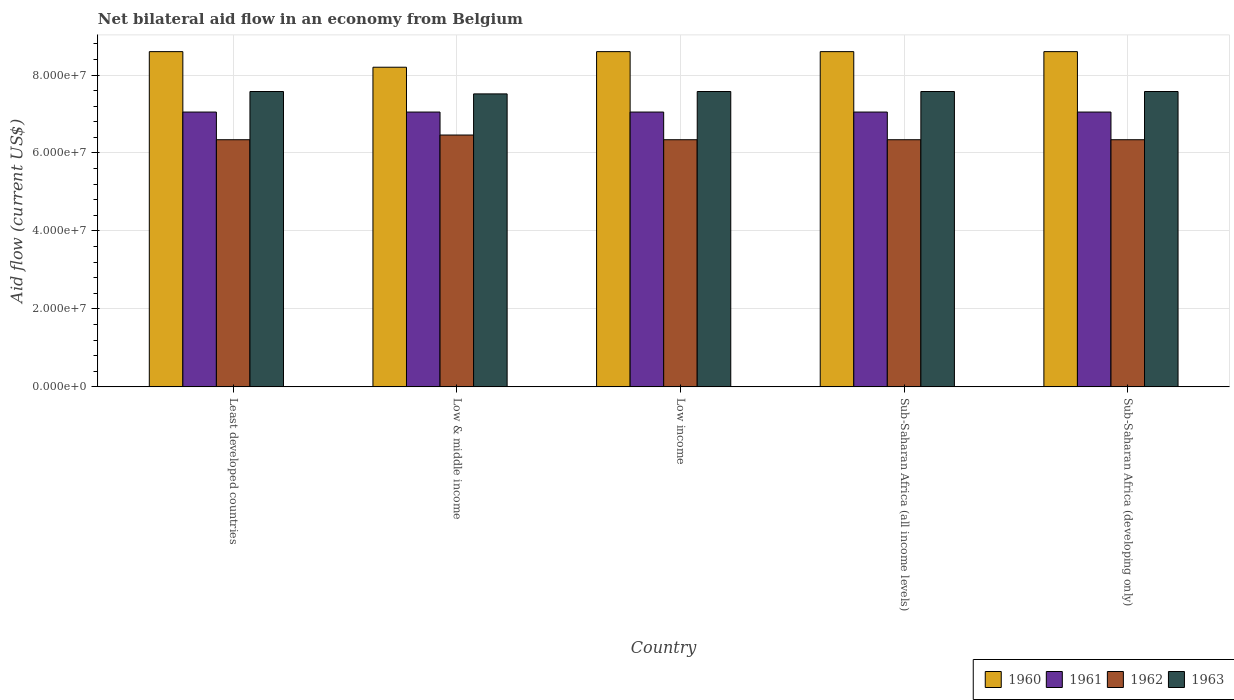How many groups of bars are there?
Offer a very short reply. 5. How many bars are there on the 5th tick from the left?
Provide a succinct answer. 4. What is the label of the 4th group of bars from the left?
Ensure brevity in your answer.  Sub-Saharan Africa (all income levels). What is the net bilateral aid flow in 1962 in Sub-Saharan Africa (all income levels)?
Ensure brevity in your answer.  6.34e+07. Across all countries, what is the maximum net bilateral aid flow in 1962?
Provide a short and direct response. 6.46e+07. Across all countries, what is the minimum net bilateral aid flow in 1962?
Make the answer very short. 6.34e+07. In which country was the net bilateral aid flow in 1960 maximum?
Your response must be concise. Least developed countries. In which country was the net bilateral aid flow in 1960 minimum?
Keep it short and to the point. Low & middle income. What is the total net bilateral aid flow in 1963 in the graph?
Offer a very short reply. 3.78e+08. What is the difference between the net bilateral aid flow in 1960 in Low & middle income and that in Sub-Saharan Africa (all income levels)?
Offer a terse response. -4.00e+06. What is the difference between the net bilateral aid flow in 1960 in Least developed countries and the net bilateral aid flow in 1961 in Low income?
Your response must be concise. 1.55e+07. What is the average net bilateral aid flow in 1962 per country?
Make the answer very short. 6.36e+07. What is the difference between the net bilateral aid flow of/in 1961 and net bilateral aid flow of/in 1963 in Least developed countries?
Offer a terse response. -5.27e+06. What is the ratio of the net bilateral aid flow in 1963 in Least developed countries to that in Low & middle income?
Keep it short and to the point. 1.01. What is the difference between the highest and the second highest net bilateral aid flow in 1962?
Give a very brief answer. 1.21e+06. What is the difference between the highest and the lowest net bilateral aid flow in 1961?
Make the answer very short. 0. In how many countries, is the net bilateral aid flow in 1960 greater than the average net bilateral aid flow in 1960 taken over all countries?
Provide a short and direct response. 4. Is it the case that in every country, the sum of the net bilateral aid flow in 1960 and net bilateral aid flow in 1961 is greater than the sum of net bilateral aid flow in 1963 and net bilateral aid flow in 1962?
Give a very brief answer. Yes. What does the 3rd bar from the left in Sub-Saharan Africa (developing only) represents?
Make the answer very short. 1962. Is it the case that in every country, the sum of the net bilateral aid flow in 1960 and net bilateral aid flow in 1962 is greater than the net bilateral aid flow in 1961?
Your answer should be very brief. Yes. How many bars are there?
Provide a short and direct response. 20. Are all the bars in the graph horizontal?
Keep it short and to the point. No. Are the values on the major ticks of Y-axis written in scientific E-notation?
Keep it short and to the point. Yes. Where does the legend appear in the graph?
Make the answer very short. Bottom right. How many legend labels are there?
Provide a succinct answer. 4. What is the title of the graph?
Offer a terse response. Net bilateral aid flow in an economy from Belgium. What is the label or title of the X-axis?
Offer a very short reply. Country. What is the label or title of the Y-axis?
Give a very brief answer. Aid flow (current US$). What is the Aid flow (current US$) in 1960 in Least developed countries?
Make the answer very short. 8.60e+07. What is the Aid flow (current US$) in 1961 in Least developed countries?
Keep it short and to the point. 7.05e+07. What is the Aid flow (current US$) in 1962 in Least developed countries?
Your answer should be very brief. 6.34e+07. What is the Aid flow (current US$) in 1963 in Least developed countries?
Your answer should be very brief. 7.58e+07. What is the Aid flow (current US$) in 1960 in Low & middle income?
Provide a succinct answer. 8.20e+07. What is the Aid flow (current US$) of 1961 in Low & middle income?
Your answer should be very brief. 7.05e+07. What is the Aid flow (current US$) of 1962 in Low & middle income?
Your answer should be compact. 6.46e+07. What is the Aid flow (current US$) in 1963 in Low & middle income?
Your answer should be compact. 7.52e+07. What is the Aid flow (current US$) in 1960 in Low income?
Your answer should be very brief. 8.60e+07. What is the Aid flow (current US$) of 1961 in Low income?
Provide a succinct answer. 7.05e+07. What is the Aid flow (current US$) of 1962 in Low income?
Provide a short and direct response. 6.34e+07. What is the Aid flow (current US$) in 1963 in Low income?
Provide a succinct answer. 7.58e+07. What is the Aid flow (current US$) in 1960 in Sub-Saharan Africa (all income levels)?
Your answer should be compact. 8.60e+07. What is the Aid flow (current US$) of 1961 in Sub-Saharan Africa (all income levels)?
Offer a very short reply. 7.05e+07. What is the Aid flow (current US$) of 1962 in Sub-Saharan Africa (all income levels)?
Keep it short and to the point. 6.34e+07. What is the Aid flow (current US$) of 1963 in Sub-Saharan Africa (all income levels)?
Make the answer very short. 7.58e+07. What is the Aid flow (current US$) of 1960 in Sub-Saharan Africa (developing only)?
Keep it short and to the point. 8.60e+07. What is the Aid flow (current US$) of 1961 in Sub-Saharan Africa (developing only)?
Ensure brevity in your answer.  7.05e+07. What is the Aid flow (current US$) in 1962 in Sub-Saharan Africa (developing only)?
Your answer should be compact. 6.34e+07. What is the Aid flow (current US$) of 1963 in Sub-Saharan Africa (developing only)?
Your answer should be compact. 7.58e+07. Across all countries, what is the maximum Aid flow (current US$) in 1960?
Make the answer very short. 8.60e+07. Across all countries, what is the maximum Aid flow (current US$) in 1961?
Give a very brief answer. 7.05e+07. Across all countries, what is the maximum Aid flow (current US$) of 1962?
Give a very brief answer. 6.46e+07. Across all countries, what is the maximum Aid flow (current US$) in 1963?
Provide a short and direct response. 7.58e+07. Across all countries, what is the minimum Aid flow (current US$) in 1960?
Provide a succinct answer. 8.20e+07. Across all countries, what is the minimum Aid flow (current US$) of 1961?
Your answer should be compact. 7.05e+07. Across all countries, what is the minimum Aid flow (current US$) in 1962?
Your response must be concise. 6.34e+07. Across all countries, what is the minimum Aid flow (current US$) of 1963?
Provide a short and direct response. 7.52e+07. What is the total Aid flow (current US$) of 1960 in the graph?
Your answer should be compact. 4.26e+08. What is the total Aid flow (current US$) in 1961 in the graph?
Provide a short and direct response. 3.52e+08. What is the total Aid flow (current US$) in 1962 in the graph?
Make the answer very short. 3.18e+08. What is the total Aid flow (current US$) of 1963 in the graph?
Provide a succinct answer. 3.78e+08. What is the difference between the Aid flow (current US$) in 1960 in Least developed countries and that in Low & middle income?
Give a very brief answer. 4.00e+06. What is the difference between the Aid flow (current US$) in 1961 in Least developed countries and that in Low & middle income?
Your response must be concise. 0. What is the difference between the Aid flow (current US$) of 1962 in Least developed countries and that in Low & middle income?
Provide a short and direct response. -1.21e+06. What is the difference between the Aid flow (current US$) in 1960 in Least developed countries and that in Low income?
Ensure brevity in your answer.  0. What is the difference between the Aid flow (current US$) in 1961 in Least developed countries and that in Low income?
Ensure brevity in your answer.  0. What is the difference between the Aid flow (current US$) of 1963 in Least developed countries and that in Sub-Saharan Africa (all income levels)?
Ensure brevity in your answer.  0. What is the difference between the Aid flow (current US$) of 1960 in Least developed countries and that in Sub-Saharan Africa (developing only)?
Your answer should be very brief. 0. What is the difference between the Aid flow (current US$) of 1963 in Least developed countries and that in Sub-Saharan Africa (developing only)?
Give a very brief answer. 0. What is the difference between the Aid flow (current US$) of 1962 in Low & middle income and that in Low income?
Ensure brevity in your answer.  1.21e+06. What is the difference between the Aid flow (current US$) of 1963 in Low & middle income and that in Low income?
Offer a very short reply. -6.10e+05. What is the difference between the Aid flow (current US$) in 1961 in Low & middle income and that in Sub-Saharan Africa (all income levels)?
Your answer should be compact. 0. What is the difference between the Aid flow (current US$) of 1962 in Low & middle income and that in Sub-Saharan Africa (all income levels)?
Offer a terse response. 1.21e+06. What is the difference between the Aid flow (current US$) in 1963 in Low & middle income and that in Sub-Saharan Africa (all income levels)?
Offer a very short reply. -6.10e+05. What is the difference between the Aid flow (current US$) in 1962 in Low & middle income and that in Sub-Saharan Africa (developing only)?
Your response must be concise. 1.21e+06. What is the difference between the Aid flow (current US$) in 1963 in Low & middle income and that in Sub-Saharan Africa (developing only)?
Provide a succinct answer. -6.10e+05. What is the difference between the Aid flow (current US$) in 1960 in Low income and that in Sub-Saharan Africa (all income levels)?
Your answer should be compact. 0. What is the difference between the Aid flow (current US$) in 1961 in Low income and that in Sub-Saharan Africa (all income levels)?
Your answer should be very brief. 0. What is the difference between the Aid flow (current US$) in 1961 in Low income and that in Sub-Saharan Africa (developing only)?
Your answer should be very brief. 0. What is the difference between the Aid flow (current US$) of 1962 in Low income and that in Sub-Saharan Africa (developing only)?
Provide a succinct answer. 0. What is the difference between the Aid flow (current US$) of 1961 in Sub-Saharan Africa (all income levels) and that in Sub-Saharan Africa (developing only)?
Keep it short and to the point. 0. What is the difference between the Aid flow (current US$) of 1963 in Sub-Saharan Africa (all income levels) and that in Sub-Saharan Africa (developing only)?
Give a very brief answer. 0. What is the difference between the Aid flow (current US$) of 1960 in Least developed countries and the Aid flow (current US$) of 1961 in Low & middle income?
Ensure brevity in your answer.  1.55e+07. What is the difference between the Aid flow (current US$) of 1960 in Least developed countries and the Aid flow (current US$) of 1962 in Low & middle income?
Your response must be concise. 2.14e+07. What is the difference between the Aid flow (current US$) of 1960 in Least developed countries and the Aid flow (current US$) of 1963 in Low & middle income?
Your response must be concise. 1.08e+07. What is the difference between the Aid flow (current US$) of 1961 in Least developed countries and the Aid flow (current US$) of 1962 in Low & middle income?
Provide a succinct answer. 5.89e+06. What is the difference between the Aid flow (current US$) of 1961 in Least developed countries and the Aid flow (current US$) of 1963 in Low & middle income?
Give a very brief answer. -4.66e+06. What is the difference between the Aid flow (current US$) of 1962 in Least developed countries and the Aid flow (current US$) of 1963 in Low & middle income?
Ensure brevity in your answer.  -1.18e+07. What is the difference between the Aid flow (current US$) of 1960 in Least developed countries and the Aid flow (current US$) of 1961 in Low income?
Offer a very short reply. 1.55e+07. What is the difference between the Aid flow (current US$) of 1960 in Least developed countries and the Aid flow (current US$) of 1962 in Low income?
Give a very brief answer. 2.26e+07. What is the difference between the Aid flow (current US$) of 1960 in Least developed countries and the Aid flow (current US$) of 1963 in Low income?
Ensure brevity in your answer.  1.02e+07. What is the difference between the Aid flow (current US$) of 1961 in Least developed countries and the Aid flow (current US$) of 1962 in Low income?
Your response must be concise. 7.10e+06. What is the difference between the Aid flow (current US$) in 1961 in Least developed countries and the Aid flow (current US$) in 1963 in Low income?
Keep it short and to the point. -5.27e+06. What is the difference between the Aid flow (current US$) in 1962 in Least developed countries and the Aid flow (current US$) in 1963 in Low income?
Offer a terse response. -1.24e+07. What is the difference between the Aid flow (current US$) of 1960 in Least developed countries and the Aid flow (current US$) of 1961 in Sub-Saharan Africa (all income levels)?
Keep it short and to the point. 1.55e+07. What is the difference between the Aid flow (current US$) of 1960 in Least developed countries and the Aid flow (current US$) of 1962 in Sub-Saharan Africa (all income levels)?
Your answer should be compact. 2.26e+07. What is the difference between the Aid flow (current US$) of 1960 in Least developed countries and the Aid flow (current US$) of 1963 in Sub-Saharan Africa (all income levels)?
Your response must be concise. 1.02e+07. What is the difference between the Aid flow (current US$) of 1961 in Least developed countries and the Aid flow (current US$) of 1962 in Sub-Saharan Africa (all income levels)?
Provide a succinct answer. 7.10e+06. What is the difference between the Aid flow (current US$) in 1961 in Least developed countries and the Aid flow (current US$) in 1963 in Sub-Saharan Africa (all income levels)?
Offer a terse response. -5.27e+06. What is the difference between the Aid flow (current US$) of 1962 in Least developed countries and the Aid flow (current US$) of 1963 in Sub-Saharan Africa (all income levels)?
Your answer should be very brief. -1.24e+07. What is the difference between the Aid flow (current US$) in 1960 in Least developed countries and the Aid flow (current US$) in 1961 in Sub-Saharan Africa (developing only)?
Your response must be concise. 1.55e+07. What is the difference between the Aid flow (current US$) of 1960 in Least developed countries and the Aid flow (current US$) of 1962 in Sub-Saharan Africa (developing only)?
Provide a short and direct response. 2.26e+07. What is the difference between the Aid flow (current US$) in 1960 in Least developed countries and the Aid flow (current US$) in 1963 in Sub-Saharan Africa (developing only)?
Offer a very short reply. 1.02e+07. What is the difference between the Aid flow (current US$) of 1961 in Least developed countries and the Aid flow (current US$) of 1962 in Sub-Saharan Africa (developing only)?
Make the answer very short. 7.10e+06. What is the difference between the Aid flow (current US$) in 1961 in Least developed countries and the Aid flow (current US$) in 1963 in Sub-Saharan Africa (developing only)?
Offer a terse response. -5.27e+06. What is the difference between the Aid flow (current US$) of 1962 in Least developed countries and the Aid flow (current US$) of 1963 in Sub-Saharan Africa (developing only)?
Provide a short and direct response. -1.24e+07. What is the difference between the Aid flow (current US$) of 1960 in Low & middle income and the Aid flow (current US$) of 1961 in Low income?
Provide a succinct answer. 1.15e+07. What is the difference between the Aid flow (current US$) in 1960 in Low & middle income and the Aid flow (current US$) in 1962 in Low income?
Give a very brief answer. 1.86e+07. What is the difference between the Aid flow (current US$) of 1960 in Low & middle income and the Aid flow (current US$) of 1963 in Low income?
Provide a succinct answer. 6.23e+06. What is the difference between the Aid flow (current US$) of 1961 in Low & middle income and the Aid flow (current US$) of 1962 in Low income?
Make the answer very short. 7.10e+06. What is the difference between the Aid flow (current US$) of 1961 in Low & middle income and the Aid flow (current US$) of 1963 in Low income?
Offer a very short reply. -5.27e+06. What is the difference between the Aid flow (current US$) in 1962 in Low & middle income and the Aid flow (current US$) in 1963 in Low income?
Make the answer very short. -1.12e+07. What is the difference between the Aid flow (current US$) of 1960 in Low & middle income and the Aid flow (current US$) of 1961 in Sub-Saharan Africa (all income levels)?
Keep it short and to the point. 1.15e+07. What is the difference between the Aid flow (current US$) of 1960 in Low & middle income and the Aid flow (current US$) of 1962 in Sub-Saharan Africa (all income levels)?
Your answer should be very brief. 1.86e+07. What is the difference between the Aid flow (current US$) of 1960 in Low & middle income and the Aid flow (current US$) of 1963 in Sub-Saharan Africa (all income levels)?
Offer a terse response. 6.23e+06. What is the difference between the Aid flow (current US$) in 1961 in Low & middle income and the Aid flow (current US$) in 1962 in Sub-Saharan Africa (all income levels)?
Provide a succinct answer. 7.10e+06. What is the difference between the Aid flow (current US$) of 1961 in Low & middle income and the Aid flow (current US$) of 1963 in Sub-Saharan Africa (all income levels)?
Make the answer very short. -5.27e+06. What is the difference between the Aid flow (current US$) of 1962 in Low & middle income and the Aid flow (current US$) of 1963 in Sub-Saharan Africa (all income levels)?
Provide a short and direct response. -1.12e+07. What is the difference between the Aid flow (current US$) in 1960 in Low & middle income and the Aid flow (current US$) in 1961 in Sub-Saharan Africa (developing only)?
Your answer should be compact. 1.15e+07. What is the difference between the Aid flow (current US$) of 1960 in Low & middle income and the Aid flow (current US$) of 1962 in Sub-Saharan Africa (developing only)?
Keep it short and to the point. 1.86e+07. What is the difference between the Aid flow (current US$) in 1960 in Low & middle income and the Aid flow (current US$) in 1963 in Sub-Saharan Africa (developing only)?
Ensure brevity in your answer.  6.23e+06. What is the difference between the Aid flow (current US$) in 1961 in Low & middle income and the Aid flow (current US$) in 1962 in Sub-Saharan Africa (developing only)?
Your response must be concise. 7.10e+06. What is the difference between the Aid flow (current US$) in 1961 in Low & middle income and the Aid flow (current US$) in 1963 in Sub-Saharan Africa (developing only)?
Offer a very short reply. -5.27e+06. What is the difference between the Aid flow (current US$) of 1962 in Low & middle income and the Aid flow (current US$) of 1963 in Sub-Saharan Africa (developing only)?
Make the answer very short. -1.12e+07. What is the difference between the Aid flow (current US$) in 1960 in Low income and the Aid flow (current US$) in 1961 in Sub-Saharan Africa (all income levels)?
Your response must be concise. 1.55e+07. What is the difference between the Aid flow (current US$) of 1960 in Low income and the Aid flow (current US$) of 1962 in Sub-Saharan Africa (all income levels)?
Provide a short and direct response. 2.26e+07. What is the difference between the Aid flow (current US$) in 1960 in Low income and the Aid flow (current US$) in 1963 in Sub-Saharan Africa (all income levels)?
Offer a very short reply. 1.02e+07. What is the difference between the Aid flow (current US$) in 1961 in Low income and the Aid flow (current US$) in 1962 in Sub-Saharan Africa (all income levels)?
Keep it short and to the point. 7.10e+06. What is the difference between the Aid flow (current US$) of 1961 in Low income and the Aid flow (current US$) of 1963 in Sub-Saharan Africa (all income levels)?
Give a very brief answer. -5.27e+06. What is the difference between the Aid flow (current US$) of 1962 in Low income and the Aid flow (current US$) of 1963 in Sub-Saharan Africa (all income levels)?
Provide a succinct answer. -1.24e+07. What is the difference between the Aid flow (current US$) of 1960 in Low income and the Aid flow (current US$) of 1961 in Sub-Saharan Africa (developing only)?
Your answer should be very brief. 1.55e+07. What is the difference between the Aid flow (current US$) of 1960 in Low income and the Aid flow (current US$) of 1962 in Sub-Saharan Africa (developing only)?
Offer a terse response. 2.26e+07. What is the difference between the Aid flow (current US$) in 1960 in Low income and the Aid flow (current US$) in 1963 in Sub-Saharan Africa (developing only)?
Offer a terse response. 1.02e+07. What is the difference between the Aid flow (current US$) in 1961 in Low income and the Aid flow (current US$) in 1962 in Sub-Saharan Africa (developing only)?
Your answer should be very brief. 7.10e+06. What is the difference between the Aid flow (current US$) in 1961 in Low income and the Aid flow (current US$) in 1963 in Sub-Saharan Africa (developing only)?
Keep it short and to the point. -5.27e+06. What is the difference between the Aid flow (current US$) in 1962 in Low income and the Aid flow (current US$) in 1963 in Sub-Saharan Africa (developing only)?
Offer a terse response. -1.24e+07. What is the difference between the Aid flow (current US$) of 1960 in Sub-Saharan Africa (all income levels) and the Aid flow (current US$) of 1961 in Sub-Saharan Africa (developing only)?
Provide a short and direct response. 1.55e+07. What is the difference between the Aid flow (current US$) of 1960 in Sub-Saharan Africa (all income levels) and the Aid flow (current US$) of 1962 in Sub-Saharan Africa (developing only)?
Offer a very short reply. 2.26e+07. What is the difference between the Aid flow (current US$) in 1960 in Sub-Saharan Africa (all income levels) and the Aid flow (current US$) in 1963 in Sub-Saharan Africa (developing only)?
Keep it short and to the point. 1.02e+07. What is the difference between the Aid flow (current US$) of 1961 in Sub-Saharan Africa (all income levels) and the Aid flow (current US$) of 1962 in Sub-Saharan Africa (developing only)?
Your response must be concise. 7.10e+06. What is the difference between the Aid flow (current US$) in 1961 in Sub-Saharan Africa (all income levels) and the Aid flow (current US$) in 1963 in Sub-Saharan Africa (developing only)?
Provide a short and direct response. -5.27e+06. What is the difference between the Aid flow (current US$) of 1962 in Sub-Saharan Africa (all income levels) and the Aid flow (current US$) of 1963 in Sub-Saharan Africa (developing only)?
Your answer should be very brief. -1.24e+07. What is the average Aid flow (current US$) of 1960 per country?
Your response must be concise. 8.52e+07. What is the average Aid flow (current US$) of 1961 per country?
Ensure brevity in your answer.  7.05e+07. What is the average Aid flow (current US$) in 1962 per country?
Make the answer very short. 6.36e+07. What is the average Aid flow (current US$) in 1963 per country?
Give a very brief answer. 7.56e+07. What is the difference between the Aid flow (current US$) of 1960 and Aid flow (current US$) of 1961 in Least developed countries?
Your response must be concise. 1.55e+07. What is the difference between the Aid flow (current US$) in 1960 and Aid flow (current US$) in 1962 in Least developed countries?
Offer a very short reply. 2.26e+07. What is the difference between the Aid flow (current US$) of 1960 and Aid flow (current US$) of 1963 in Least developed countries?
Make the answer very short. 1.02e+07. What is the difference between the Aid flow (current US$) of 1961 and Aid flow (current US$) of 1962 in Least developed countries?
Your answer should be compact. 7.10e+06. What is the difference between the Aid flow (current US$) of 1961 and Aid flow (current US$) of 1963 in Least developed countries?
Keep it short and to the point. -5.27e+06. What is the difference between the Aid flow (current US$) in 1962 and Aid flow (current US$) in 1963 in Least developed countries?
Provide a short and direct response. -1.24e+07. What is the difference between the Aid flow (current US$) of 1960 and Aid flow (current US$) of 1961 in Low & middle income?
Keep it short and to the point. 1.15e+07. What is the difference between the Aid flow (current US$) in 1960 and Aid flow (current US$) in 1962 in Low & middle income?
Keep it short and to the point. 1.74e+07. What is the difference between the Aid flow (current US$) in 1960 and Aid flow (current US$) in 1963 in Low & middle income?
Offer a very short reply. 6.84e+06. What is the difference between the Aid flow (current US$) of 1961 and Aid flow (current US$) of 1962 in Low & middle income?
Your response must be concise. 5.89e+06. What is the difference between the Aid flow (current US$) in 1961 and Aid flow (current US$) in 1963 in Low & middle income?
Your answer should be very brief. -4.66e+06. What is the difference between the Aid flow (current US$) in 1962 and Aid flow (current US$) in 1963 in Low & middle income?
Provide a succinct answer. -1.06e+07. What is the difference between the Aid flow (current US$) of 1960 and Aid flow (current US$) of 1961 in Low income?
Provide a short and direct response. 1.55e+07. What is the difference between the Aid flow (current US$) of 1960 and Aid flow (current US$) of 1962 in Low income?
Give a very brief answer. 2.26e+07. What is the difference between the Aid flow (current US$) of 1960 and Aid flow (current US$) of 1963 in Low income?
Give a very brief answer. 1.02e+07. What is the difference between the Aid flow (current US$) of 1961 and Aid flow (current US$) of 1962 in Low income?
Provide a short and direct response. 7.10e+06. What is the difference between the Aid flow (current US$) of 1961 and Aid flow (current US$) of 1963 in Low income?
Your answer should be very brief. -5.27e+06. What is the difference between the Aid flow (current US$) in 1962 and Aid flow (current US$) in 1963 in Low income?
Make the answer very short. -1.24e+07. What is the difference between the Aid flow (current US$) in 1960 and Aid flow (current US$) in 1961 in Sub-Saharan Africa (all income levels)?
Your response must be concise. 1.55e+07. What is the difference between the Aid flow (current US$) of 1960 and Aid flow (current US$) of 1962 in Sub-Saharan Africa (all income levels)?
Ensure brevity in your answer.  2.26e+07. What is the difference between the Aid flow (current US$) in 1960 and Aid flow (current US$) in 1963 in Sub-Saharan Africa (all income levels)?
Provide a succinct answer. 1.02e+07. What is the difference between the Aid flow (current US$) of 1961 and Aid flow (current US$) of 1962 in Sub-Saharan Africa (all income levels)?
Ensure brevity in your answer.  7.10e+06. What is the difference between the Aid flow (current US$) in 1961 and Aid flow (current US$) in 1963 in Sub-Saharan Africa (all income levels)?
Make the answer very short. -5.27e+06. What is the difference between the Aid flow (current US$) of 1962 and Aid flow (current US$) of 1963 in Sub-Saharan Africa (all income levels)?
Ensure brevity in your answer.  -1.24e+07. What is the difference between the Aid flow (current US$) in 1960 and Aid flow (current US$) in 1961 in Sub-Saharan Africa (developing only)?
Your response must be concise. 1.55e+07. What is the difference between the Aid flow (current US$) of 1960 and Aid flow (current US$) of 1962 in Sub-Saharan Africa (developing only)?
Your response must be concise. 2.26e+07. What is the difference between the Aid flow (current US$) of 1960 and Aid flow (current US$) of 1963 in Sub-Saharan Africa (developing only)?
Give a very brief answer. 1.02e+07. What is the difference between the Aid flow (current US$) of 1961 and Aid flow (current US$) of 1962 in Sub-Saharan Africa (developing only)?
Your response must be concise. 7.10e+06. What is the difference between the Aid flow (current US$) in 1961 and Aid flow (current US$) in 1963 in Sub-Saharan Africa (developing only)?
Offer a terse response. -5.27e+06. What is the difference between the Aid flow (current US$) of 1962 and Aid flow (current US$) of 1963 in Sub-Saharan Africa (developing only)?
Your answer should be very brief. -1.24e+07. What is the ratio of the Aid flow (current US$) in 1960 in Least developed countries to that in Low & middle income?
Your answer should be compact. 1.05. What is the ratio of the Aid flow (current US$) in 1962 in Least developed countries to that in Low & middle income?
Ensure brevity in your answer.  0.98. What is the ratio of the Aid flow (current US$) of 1960 in Least developed countries to that in Low income?
Provide a short and direct response. 1. What is the ratio of the Aid flow (current US$) in 1963 in Least developed countries to that in Low income?
Offer a very short reply. 1. What is the ratio of the Aid flow (current US$) in 1961 in Least developed countries to that in Sub-Saharan Africa (all income levels)?
Your answer should be very brief. 1. What is the ratio of the Aid flow (current US$) in 1960 in Least developed countries to that in Sub-Saharan Africa (developing only)?
Make the answer very short. 1. What is the ratio of the Aid flow (current US$) of 1960 in Low & middle income to that in Low income?
Keep it short and to the point. 0.95. What is the ratio of the Aid flow (current US$) of 1962 in Low & middle income to that in Low income?
Your answer should be compact. 1.02. What is the ratio of the Aid flow (current US$) in 1960 in Low & middle income to that in Sub-Saharan Africa (all income levels)?
Your answer should be compact. 0.95. What is the ratio of the Aid flow (current US$) of 1962 in Low & middle income to that in Sub-Saharan Africa (all income levels)?
Ensure brevity in your answer.  1.02. What is the ratio of the Aid flow (current US$) in 1963 in Low & middle income to that in Sub-Saharan Africa (all income levels)?
Make the answer very short. 0.99. What is the ratio of the Aid flow (current US$) in 1960 in Low & middle income to that in Sub-Saharan Africa (developing only)?
Your response must be concise. 0.95. What is the ratio of the Aid flow (current US$) in 1961 in Low & middle income to that in Sub-Saharan Africa (developing only)?
Provide a short and direct response. 1. What is the ratio of the Aid flow (current US$) of 1962 in Low & middle income to that in Sub-Saharan Africa (developing only)?
Give a very brief answer. 1.02. What is the ratio of the Aid flow (current US$) of 1960 in Low income to that in Sub-Saharan Africa (all income levels)?
Offer a very short reply. 1. What is the ratio of the Aid flow (current US$) in 1962 in Low income to that in Sub-Saharan Africa (developing only)?
Provide a short and direct response. 1. What is the ratio of the Aid flow (current US$) in 1961 in Sub-Saharan Africa (all income levels) to that in Sub-Saharan Africa (developing only)?
Give a very brief answer. 1. What is the ratio of the Aid flow (current US$) in 1962 in Sub-Saharan Africa (all income levels) to that in Sub-Saharan Africa (developing only)?
Offer a terse response. 1. What is the difference between the highest and the second highest Aid flow (current US$) of 1960?
Make the answer very short. 0. What is the difference between the highest and the second highest Aid flow (current US$) in 1961?
Give a very brief answer. 0. What is the difference between the highest and the second highest Aid flow (current US$) in 1962?
Your response must be concise. 1.21e+06. What is the difference between the highest and the lowest Aid flow (current US$) of 1962?
Your answer should be very brief. 1.21e+06. What is the difference between the highest and the lowest Aid flow (current US$) in 1963?
Give a very brief answer. 6.10e+05. 